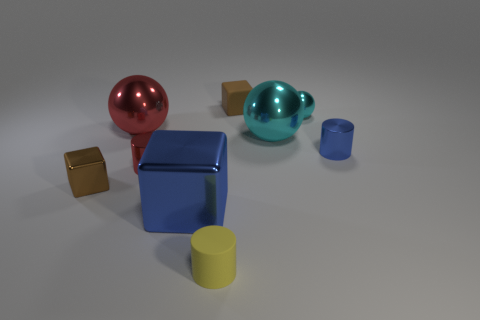Does the matte cube have the same color as the small metal block?
Provide a short and direct response. Yes. Is there anything else that is the same color as the matte cylinder?
Your response must be concise. No. What number of tiny things are purple rubber objects or blue shiny cubes?
Your response must be concise. 0. Does the metallic cylinder right of the blue block have the same color as the big metallic block?
Offer a very short reply. Yes. Do the matte object behind the yellow matte thing and the tiny block that is in front of the brown rubber thing have the same color?
Ensure brevity in your answer.  Yes. Are there any tiny brown blocks made of the same material as the yellow thing?
Offer a very short reply. Yes. What number of gray things are big metal things or large cylinders?
Your response must be concise. 0. Are there more large blue objects in front of the large red metal thing than small gray matte cylinders?
Ensure brevity in your answer.  Yes. Do the red metallic sphere and the red cylinder have the same size?
Provide a short and direct response. No. There is another small thing that is the same material as the yellow thing; what is its color?
Your response must be concise. Brown. 